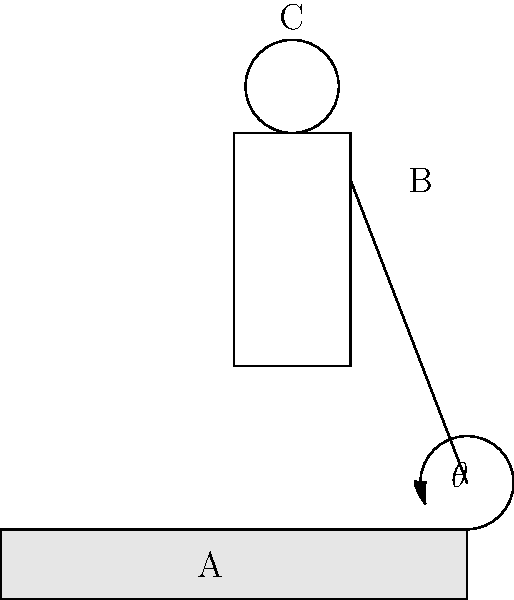In the ergonomic analysis of playing the guqin, a traditional Chinese string instrument, consider the diagram above. The player's arm forms an angle $\theta$ with the horizontal plane of the instrument. If the distance from the player's shoulder (point B) to the contact point on the guqin (point A) is 40 cm, and the vertical distance from the shoulder to the top of the head (point C) is 25 cm, what is the approximate angle $\theta$ that minimizes strain on the player's arm and shoulder? To find the optimal angle $\theta$ that minimizes strain, we can follow these steps:

1) First, we need to consider the ergonomic principle that the arm should be in a natural, relaxed position. This often corresponds to an angle where the forearm is roughly perpendicular to the upper arm.

2) Given the dimensions:
   - Distance from shoulder to guqin contact point (BA) = 40 cm
   - Vertical distance from shoulder to top of head (BC) = 25 cm

3) We can use these measurements to estimate the optimal angle. A common ergonomic recommendation is to have the elbow at about the same height as the bottom of the rib cage, which is typically around 2/3 of the distance from shoulder to top of head.

4) So, the ideal height of the elbow would be approximately:
   $\frac{2}{3} \times 25 \text{ cm} = 16.67 \text{ cm}$

5) Now we can use trigonometry to find the angle. We have:
   - Adjacent side (horizontal distance) = 40 cm
   - Opposite side (vertical distance) ≈ 16.67 cm

6) Using the tangent function:
   $\tan(\theta) = \frac{\text{opposite}}{\text{adjacent}} = \frac{16.67}{40}$

7) Solving for $\theta$:
   $\theta = \arctan(\frac{16.67}{40}) \approx 22.6°$

8) Rounding to the nearest degree for practical application:
   $\theta \approx 23°$

This angle should provide a comfortable playing position that minimizes strain on the arm and shoulder while playing the guqin.
Answer: 23° 